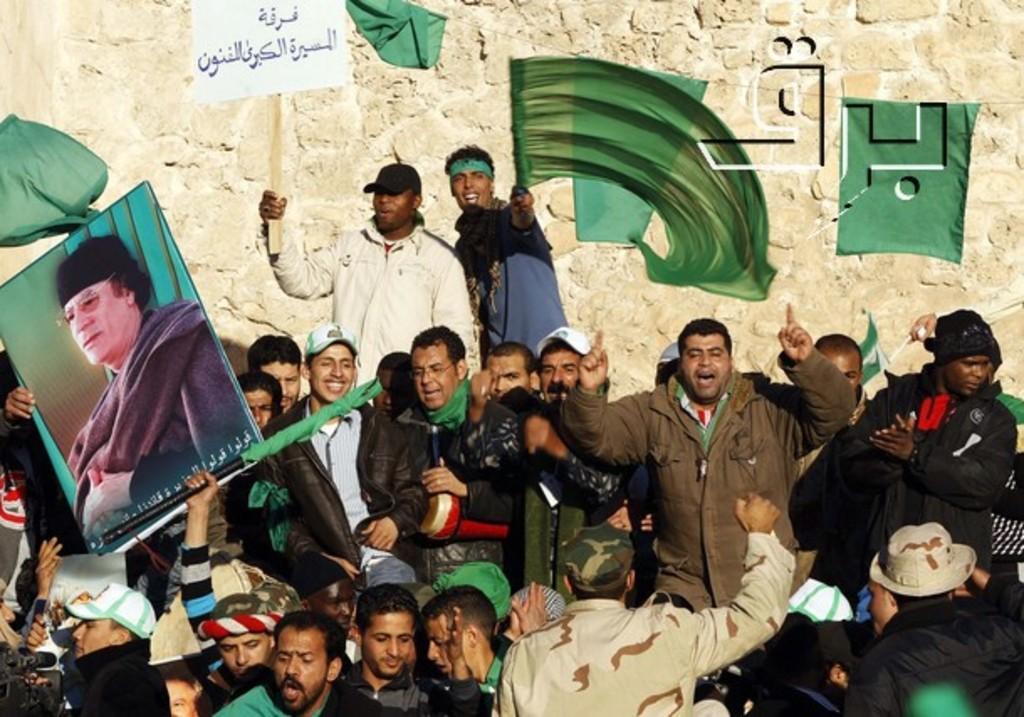Could you give a brief overview of what you see in this image? In this image there are group of people some of them are holding some boards, and some of them are holding flags and some of them are shouting. And in the background there is wall. 